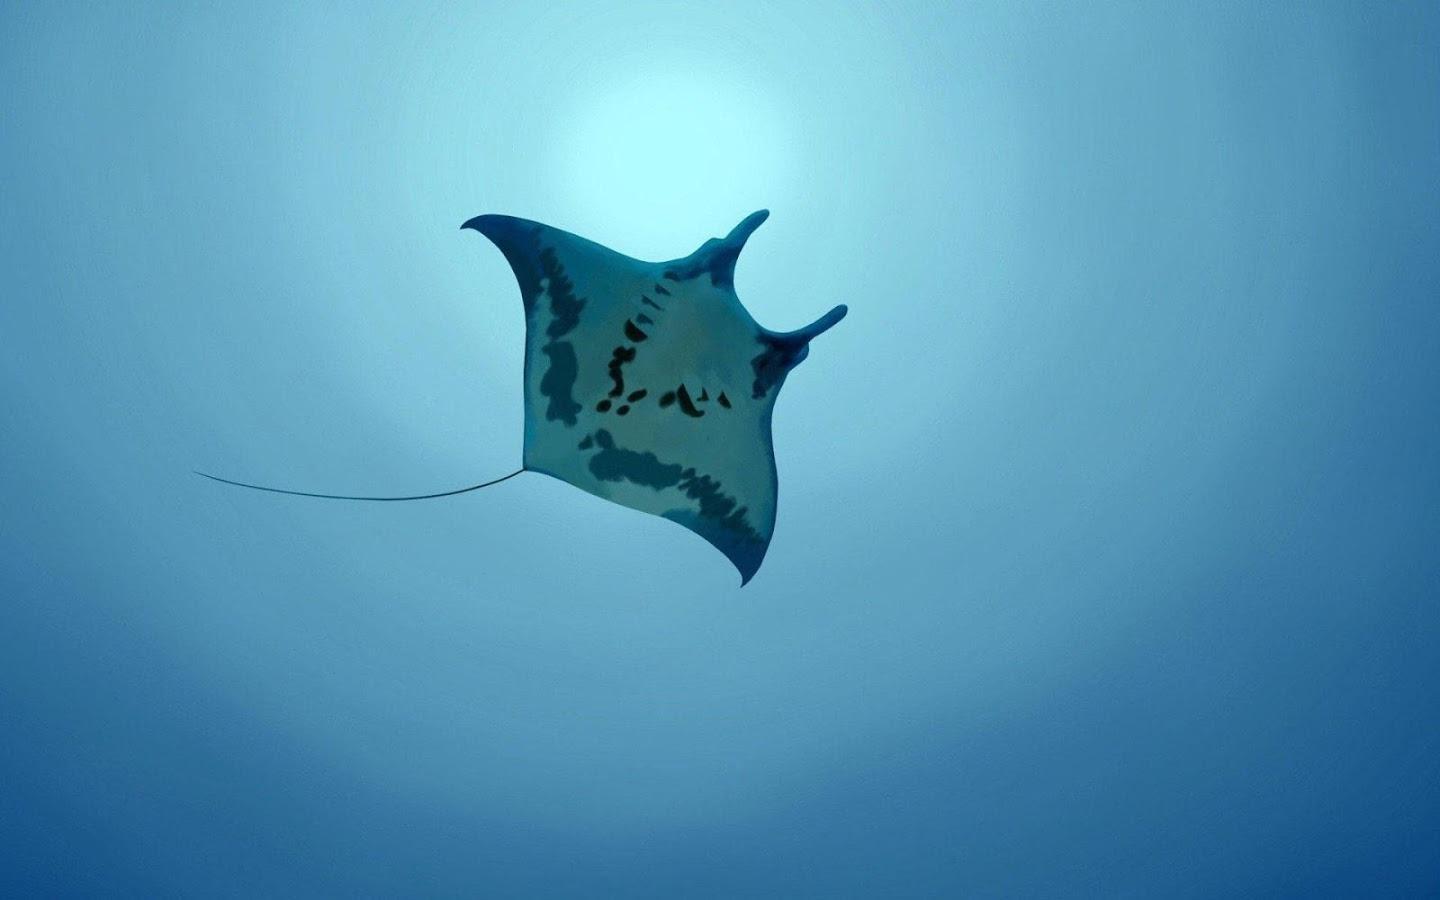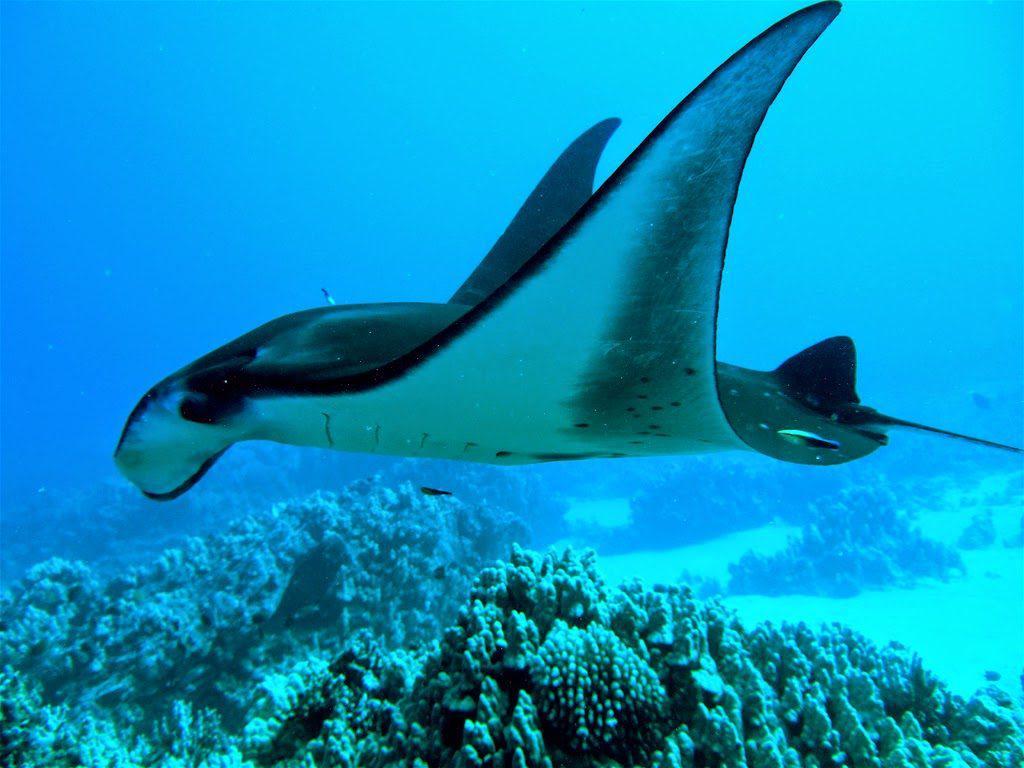The first image is the image on the left, the second image is the image on the right. Given the left and right images, does the statement "The right image features two rays." hold true? Answer yes or no. No. The first image is the image on the left, the second image is the image on the right. For the images displayed, is the sentence "a stingray is moving the sandy ocean bottom move while swimming" factually correct? Answer yes or no. No. 